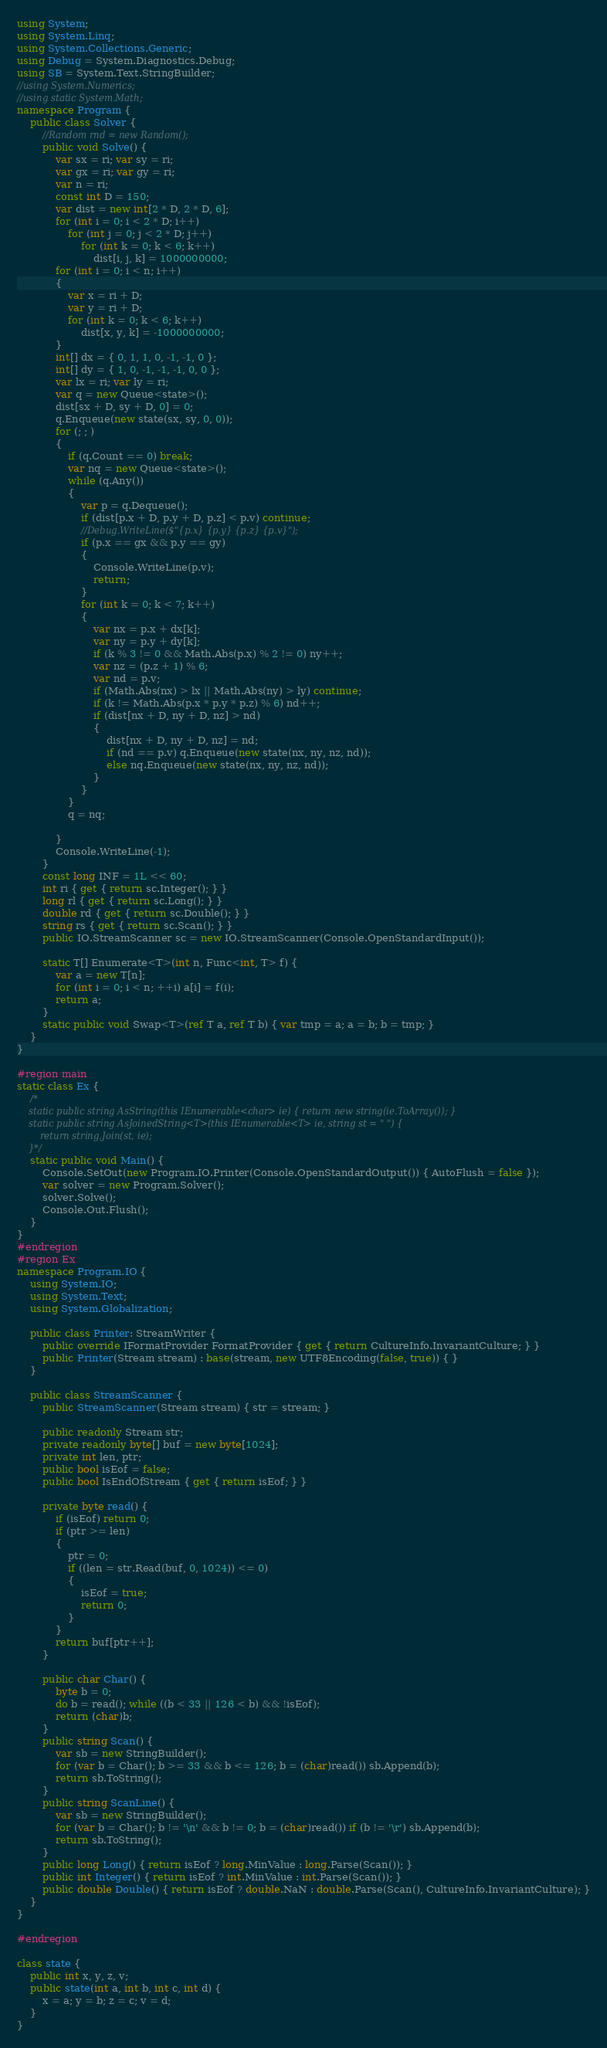Convert code to text. <code><loc_0><loc_0><loc_500><loc_500><_C#_>using System;
using System.Linq;
using System.Collections.Generic;
using Debug = System.Diagnostics.Debug;
using SB = System.Text.StringBuilder;
//using System.Numerics;
//using static System.Math;
namespace Program {
    public class Solver {
        //Random rnd = new Random();
        public void Solve() {
            var sx = ri; var sy = ri;
            var gx = ri; var gy = ri;
            var n = ri;
            const int D = 150;
            var dist = new int[2 * D, 2 * D, 6];
            for (int i = 0; i < 2 * D; i++)
                for (int j = 0; j < 2 * D; j++)
                    for (int k = 0; k < 6; k++)
                        dist[i, j, k] = 1000000000;
            for (int i = 0; i < n; i++)
            {
                var x = ri + D;
                var y = ri + D;
                for (int k = 0; k < 6; k++)
                    dist[x, y, k] = -1000000000;
            }
            int[] dx = { 0, 1, 1, 0, -1, -1, 0 };
            int[] dy = { 1, 0, -1, -1, -1, 0, 0 };
            var lx = ri; var ly = ri;
            var q = new Queue<state>();
            dist[sx + D, sy + D, 0] = 0;
            q.Enqueue(new state(sx, sy, 0, 0));
            for (; ; )
            {
                if (q.Count == 0) break;
                var nq = new Queue<state>();
                while (q.Any())
                {
                    var p = q.Dequeue();
                    if (dist[p.x + D, p.y + D, p.z] < p.v) continue;
                    //Debug.WriteLine($"{p.x} {p.y} {p.z} {p.v}");
                    if (p.x == gx && p.y == gy)
                    {
                        Console.WriteLine(p.v);
                        return;
                    }
                    for (int k = 0; k < 7; k++)
                    {
                        var nx = p.x + dx[k];
                        var ny = p.y + dy[k];
                        if (k % 3 != 0 && Math.Abs(p.x) % 2 != 0) ny++;
                        var nz = (p.z + 1) % 6;
                        var nd = p.v;
                        if (Math.Abs(nx) > lx || Math.Abs(ny) > ly) continue;
                        if (k != Math.Abs(p.x * p.y * p.z) % 6) nd++;
                        if (dist[nx + D, ny + D, nz] > nd)
                        {
                            dist[nx + D, ny + D, nz] = nd;
                            if (nd == p.v) q.Enqueue(new state(nx, ny, nz, nd));
                            else nq.Enqueue(new state(nx, ny, nz, nd));
                        }
                    }
                }
                q = nq;

            }
            Console.WriteLine(-1);
        }
        const long INF = 1L << 60;
        int ri { get { return sc.Integer(); } }
        long rl { get { return sc.Long(); } }
        double rd { get { return sc.Double(); } }
        string rs { get { return sc.Scan(); } }
        public IO.StreamScanner sc = new IO.StreamScanner(Console.OpenStandardInput());

        static T[] Enumerate<T>(int n, Func<int, T> f) {
            var a = new T[n];
            for (int i = 0; i < n; ++i) a[i] = f(i);
            return a;
        }
        static public void Swap<T>(ref T a, ref T b) { var tmp = a; a = b; b = tmp; }
    }
}

#region main
static class Ex {
    /*
    static public string AsString(this IEnumerable<char> ie) { return new string(ie.ToArray()); }
    static public string AsJoinedString<T>(this IEnumerable<T> ie, string st = " ") {
        return string.Join(st, ie);
    }*/
    static public void Main() {
        Console.SetOut(new Program.IO.Printer(Console.OpenStandardOutput()) { AutoFlush = false });
        var solver = new Program.Solver();
        solver.Solve();
        Console.Out.Flush();
    }
}
#endregion
#region Ex
namespace Program.IO {
    using System.IO;
    using System.Text;
    using System.Globalization;

    public class Printer: StreamWriter {
        public override IFormatProvider FormatProvider { get { return CultureInfo.InvariantCulture; } }
        public Printer(Stream stream) : base(stream, new UTF8Encoding(false, true)) { }
    }

    public class StreamScanner {
        public StreamScanner(Stream stream) { str = stream; }

        public readonly Stream str;
        private readonly byte[] buf = new byte[1024];
        private int len, ptr;
        public bool isEof = false;
        public bool IsEndOfStream { get { return isEof; } }

        private byte read() {
            if (isEof) return 0;
            if (ptr >= len)
            {
                ptr = 0;
                if ((len = str.Read(buf, 0, 1024)) <= 0)
                {
                    isEof = true;
                    return 0;
                }
            }
            return buf[ptr++];
        }

        public char Char() {
            byte b = 0;
            do b = read(); while ((b < 33 || 126 < b) && !isEof);
            return (char)b;
        }
        public string Scan() {
            var sb = new StringBuilder();
            for (var b = Char(); b >= 33 && b <= 126; b = (char)read()) sb.Append(b);
            return sb.ToString();
        }
        public string ScanLine() {
            var sb = new StringBuilder();
            for (var b = Char(); b != '\n' && b != 0; b = (char)read()) if (b != '\r') sb.Append(b);
            return sb.ToString();
        }
        public long Long() { return isEof ? long.MinValue : long.Parse(Scan()); }
        public int Integer() { return isEof ? int.MinValue : int.Parse(Scan()); }
        public double Double() { return isEof ? double.NaN : double.Parse(Scan(), CultureInfo.InvariantCulture); }
    }
}

#endregion

class state {
    public int x, y, z, v;
    public state(int a, int b, int c, int d) {
        x = a; y = b; z = c; v = d;
    }
}

</code> 